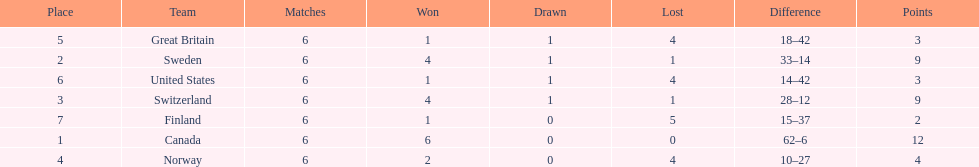How many teams won at least 2 games throughout the 1951 world ice hockey championships? 4. 